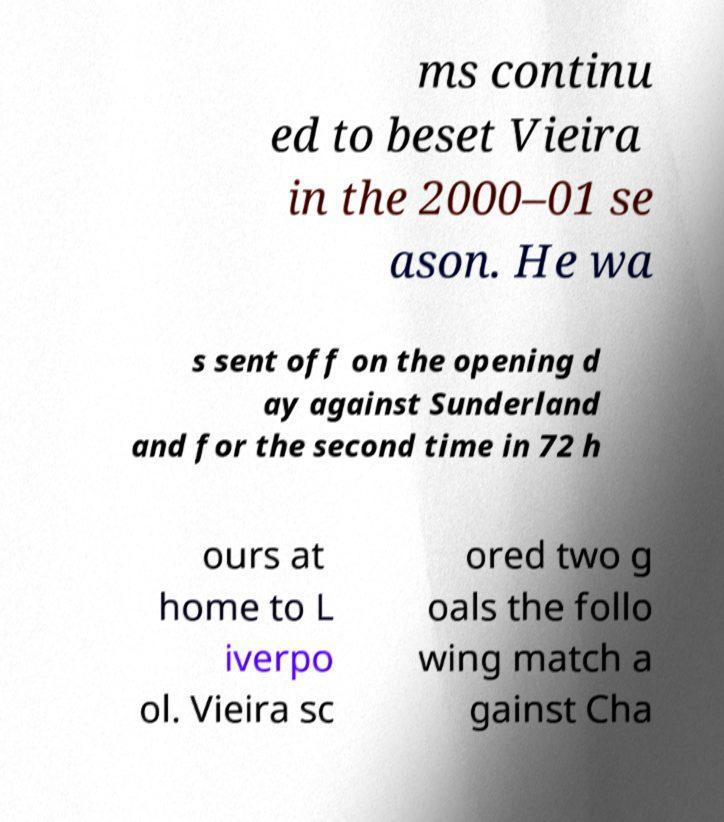Can you accurately transcribe the text from the provided image for me? ms continu ed to beset Vieira in the 2000–01 se ason. He wa s sent off on the opening d ay against Sunderland and for the second time in 72 h ours at home to L iverpo ol. Vieira sc ored two g oals the follo wing match a gainst Cha 